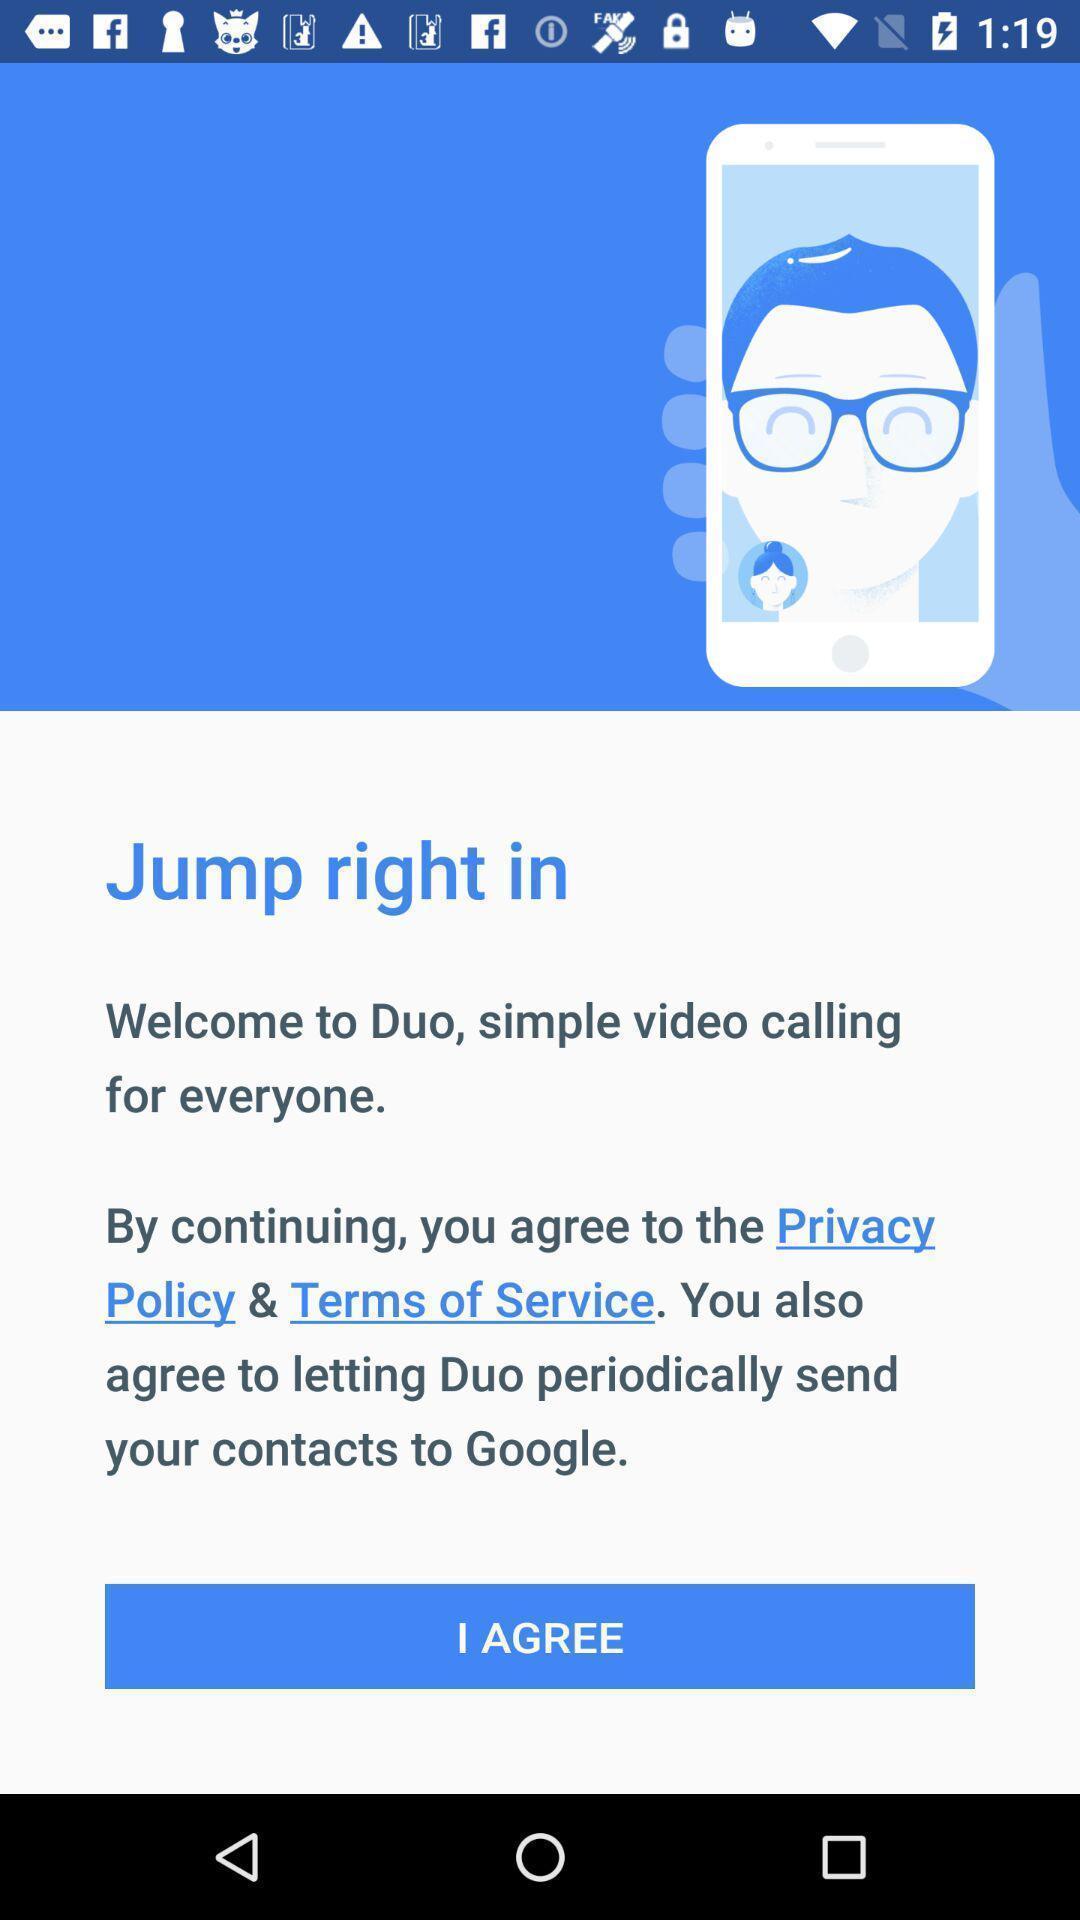Explain what's happening in this screen capture. Welcome screen with privacy policy. 